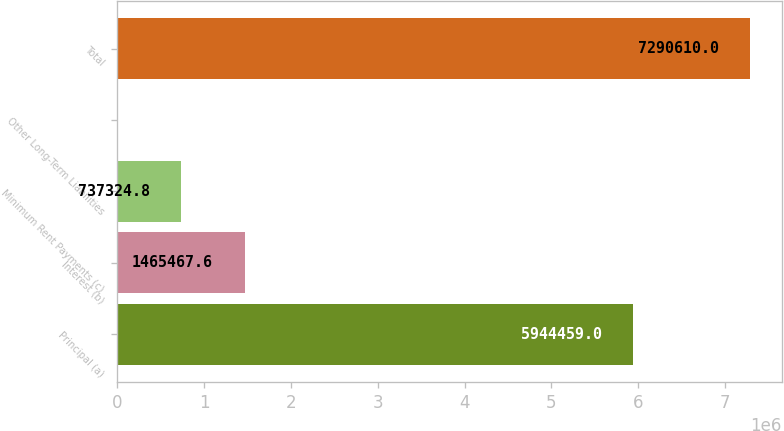Convert chart. <chart><loc_0><loc_0><loc_500><loc_500><bar_chart><fcel>Principal (a)<fcel>Interest (b)<fcel>Minimum Rent Payments (c)<fcel>Other Long-Term Liabilities<fcel>Total<nl><fcel>5.94446e+06<fcel>1.46547e+06<fcel>737325<fcel>9182<fcel>7.29061e+06<nl></chart> 